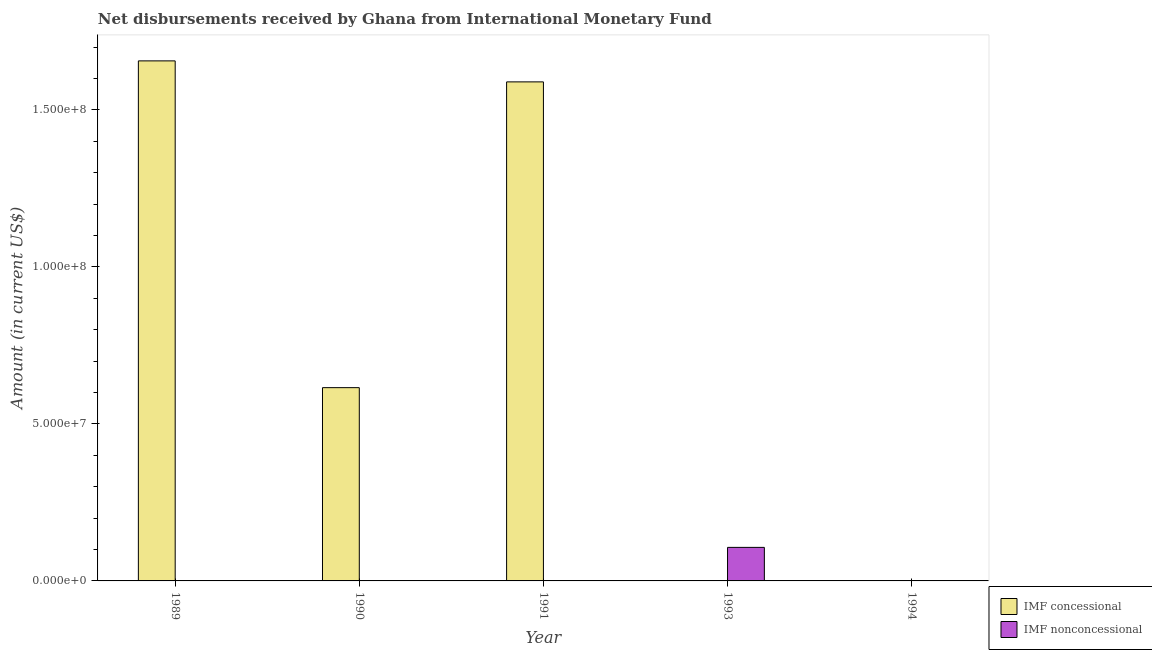How many different coloured bars are there?
Keep it short and to the point. 2. Are the number of bars on each tick of the X-axis equal?
Your response must be concise. No. How many bars are there on the 1st tick from the left?
Make the answer very short. 1. How many bars are there on the 3rd tick from the right?
Offer a terse response. 1. What is the net concessional disbursements from imf in 1989?
Provide a succinct answer. 1.66e+08. Across all years, what is the maximum net concessional disbursements from imf?
Keep it short and to the point. 1.66e+08. What is the total net concessional disbursements from imf in the graph?
Ensure brevity in your answer.  3.86e+08. What is the difference between the net concessional disbursements from imf in 1989 and that in 1991?
Offer a terse response. 6.69e+06. What is the difference between the net non concessional disbursements from imf in 1994 and the net concessional disbursements from imf in 1991?
Offer a very short reply. 0. What is the average net non concessional disbursements from imf per year?
Your answer should be very brief. 2.14e+06. In how many years, is the net non concessional disbursements from imf greater than 40000000 US$?
Offer a terse response. 0. What is the ratio of the net concessional disbursements from imf in 1989 to that in 1990?
Your answer should be very brief. 2.69. Is the net concessional disbursements from imf in 1989 less than that in 1990?
Provide a succinct answer. No. What is the difference between the highest and the second highest net concessional disbursements from imf?
Your response must be concise. 6.69e+06. What is the difference between the highest and the lowest net non concessional disbursements from imf?
Provide a succinct answer. 1.07e+07. In how many years, is the net concessional disbursements from imf greater than the average net concessional disbursements from imf taken over all years?
Keep it short and to the point. 2. Is the sum of the net concessional disbursements from imf in 1989 and 1991 greater than the maximum net non concessional disbursements from imf across all years?
Your answer should be compact. Yes. Does the graph contain any zero values?
Make the answer very short. Yes. Does the graph contain grids?
Provide a short and direct response. No. How are the legend labels stacked?
Make the answer very short. Vertical. What is the title of the graph?
Offer a terse response. Net disbursements received by Ghana from International Monetary Fund. What is the label or title of the X-axis?
Offer a terse response. Year. What is the label or title of the Y-axis?
Provide a succinct answer. Amount (in current US$). What is the Amount (in current US$) in IMF concessional in 1989?
Offer a very short reply. 1.66e+08. What is the Amount (in current US$) in IMF nonconcessional in 1989?
Offer a terse response. 0. What is the Amount (in current US$) of IMF concessional in 1990?
Provide a short and direct response. 6.15e+07. What is the Amount (in current US$) of IMF nonconcessional in 1990?
Provide a short and direct response. 0. What is the Amount (in current US$) in IMF concessional in 1991?
Give a very brief answer. 1.59e+08. What is the Amount (in current US$) of IMF nonconcessional in 1993?
Your answer should be compact. 1.07e+07. What is the Amount (in current US$) in IMF concessional in 1994?
Your response must be concise. 0. Across all years, what is the maximum Amount (in current US$) in IMF concessional?
Provide a short and direct response. 1.66e+08. Across all years, what is the maximum Amount (in current US$) in IMF nonconcessional?
Offer a terse response. 1.07e+07. Across all years, what is the minimum Amount (in current US$) of IMF concessional?
Make the answer very short. 0. What is the total Amount (in current US$) in IMF concessional in the graph?
Ensure brevity in your answer.  3.86e+08. What is the total Amount (in current US$) in IMF nonconcessional in the graph?
Ensure brevity in your answer.  1.07e+07. What is the difference between the Amount (in current US$) of IMF concessional in 1989 and that in 1990?
Your response must be concise. 1.04e+08. What is the difference between the Amount (in current US$) in IMF concessional in 1989 and that in 1991?
Provide a short and direct response. 6.69e+06. What is the difference between the Amount (in current US$) in IMF concessional in 1990 and that in 1991?
Your answer should be compact. -9.74e+07. What is the difference between the Amount (in current US$) of IMF concessional in 1989 and the Amount (in current US$) of IMF nonconcessional in 1993?
Provide a short and direct response. 1.55e+08. What is the difference between the Amount (in current US$) of IMF concessional in 1990 and the Amount (in current US$) of IMF nonconcessional in 1993?
Offer a very short reply. 5.09e+07. What is the difference between the Amount (in current US$) in IMF concessional in 1991 and the Amount (in current US$) in IMF nonconcessional in 1993?
Offer a very short reply. 1.48e+08. What is the average Amount (in current US$) in IMF concessional per year?
Give a very brief answer. 7.72e+07. What is the average Amount (in current US$) in IMF nonconcessional per year?
Provide a short and direct response. 2.14e+06. What is the ratio of the Amount (in current US$) of IMF concessional in 1989 to that in 1990?
Provide a short and direct response. 2.69. What is the ratio of the Amount (in current US$) of IMF concessional in 1989 to that in 1991?
Make the answer very short. 1.04. What is the ratio of the Amount (in current US$) in IMF concessional in 1990 to that in 1991?
Keep it short and to the point. 0.39. What is the difference between the highest and the second highest Amount (in current US$) of IMF concessional?
Offer a very short reply. 6.69e+06. What is the difference between the highest and the lowest Amount (in current US$) in IMF concessional?
Provide a short and direct response. 1.66e+08. What is the difference between the highest and the lowest Amount (in current US$) in IMF nonconcessional?
Your response must be concise. 1.07e+07. 